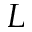<formula> <loc_0><loc_0><loc_500><loc_500>L</formula> 